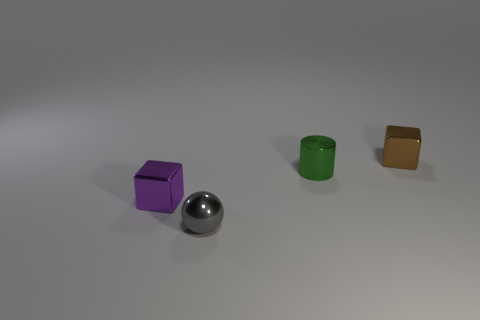Add 1 tiny cyan shiny cylinders. How many objects exist? 5 Subtract all cylinders. How many objects are left? 3 Add 2 small green cylinders. How many small green cylinders are left? 3 Add 3 tiny green metal things. How many tiny green metal things exist? 4 Subtract 0 yellow cylinders. How many objects are left? 4 Subtract all tiny metallic blocks. Subtract all cubes. How many objects are left? 0 